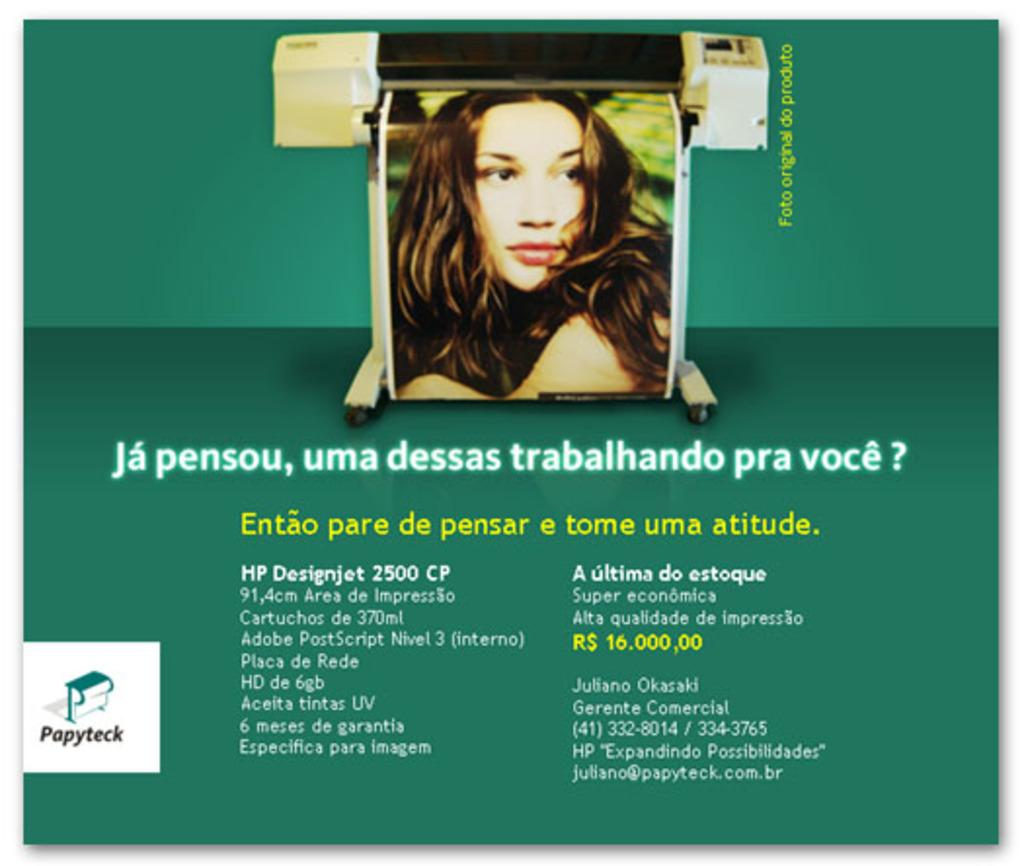What is the main object in the image? There is a poster in the image. What is depicted on the poster? The poster contains a picture of a woman. Are there any words on the poster? Yes, there is text on the poster. What type of comfort can be seen in the image? There is no reference to comfort in the image; it features a poster with a picture of a woman and text. 